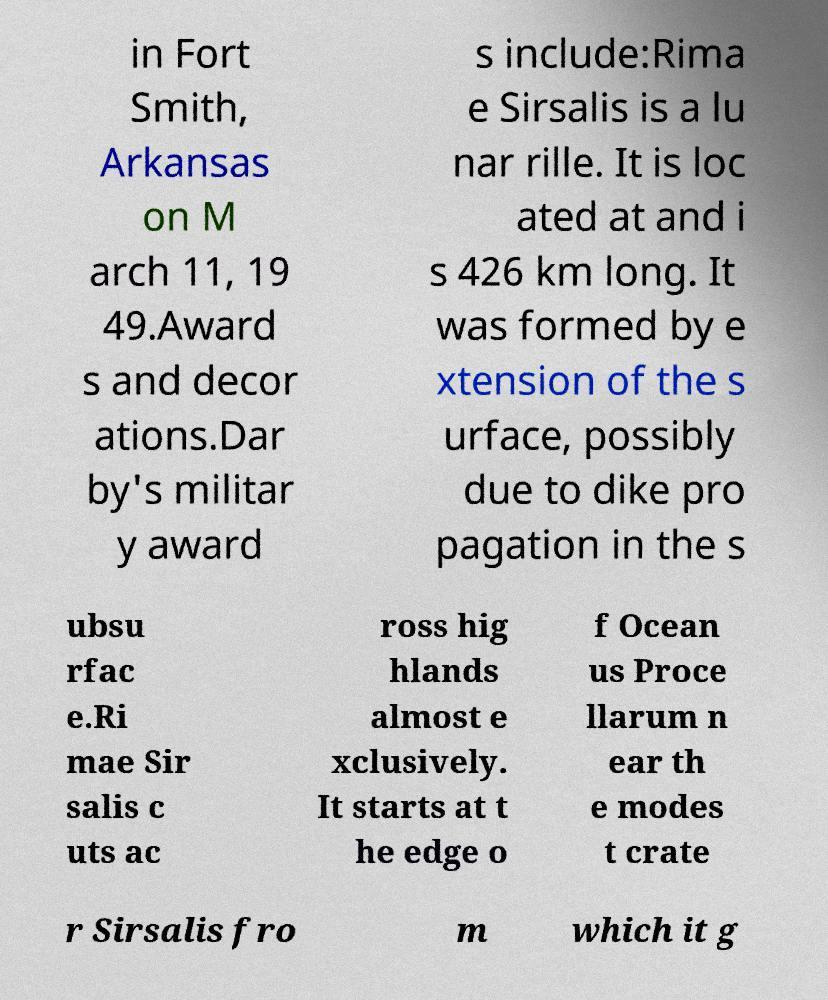There's text embedded in this image that I need extracted. Can you transcribe it verbatim? in Fort Smith, Arkansas on M arch 11, 19 49.Award s and decor ations.Dar by's militar y award s include:Rima e Sirsalis is a lu nar rille. It is loc ated at and i s 426 km long. It was formed by e xtension of the s urface, possibly due to dike pro pagation in the s ubsu rfac e.Ri mae Sir salis c uts ac ross hig hlands almost e xclusively. It starts at t he edge o f Ocean us Proce llarum n ear th e modes t crate r Sirsalis fro m which it g 